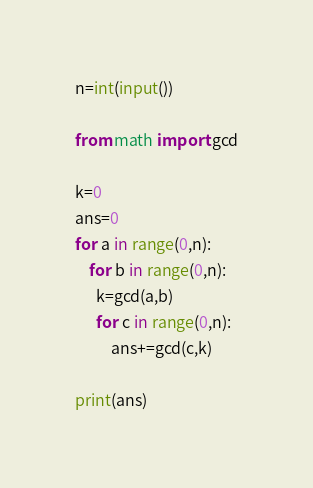<code> <loc_0><loc_0><loc_500><loc_500><_Python_>n=int(input())
 
from math import gcd
 
k=0
ans=0
for a in range(0,n):
    for b in range(0,n):
      k=gcd(a,b)
      for c in range(0,n):
          ans+=gcd(c,k)
                      
print(ans)</code> 